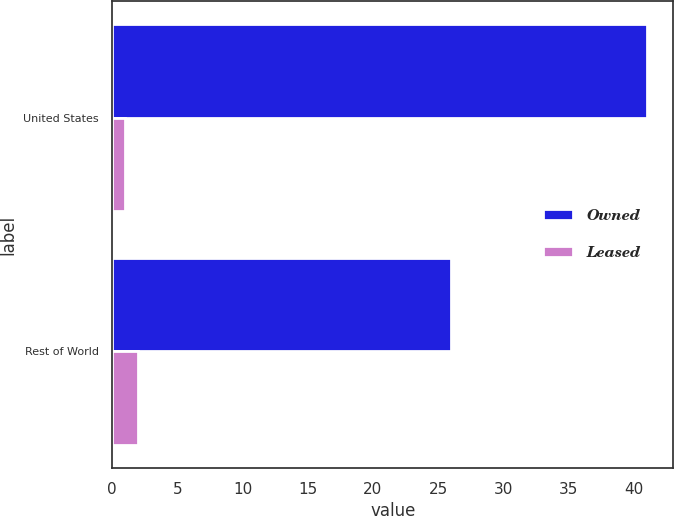Convert chart to OTSL. <chart><loc_0><loc_0><loc_500><loc_500><stacked_bar_chart><ecel><fcel>United States<fcel>Rest of World<nl><fcel>Owned<fcel>41<fcel>26<nl><fcel>Leased<fcel>1<fcel>2<nl></chart> 